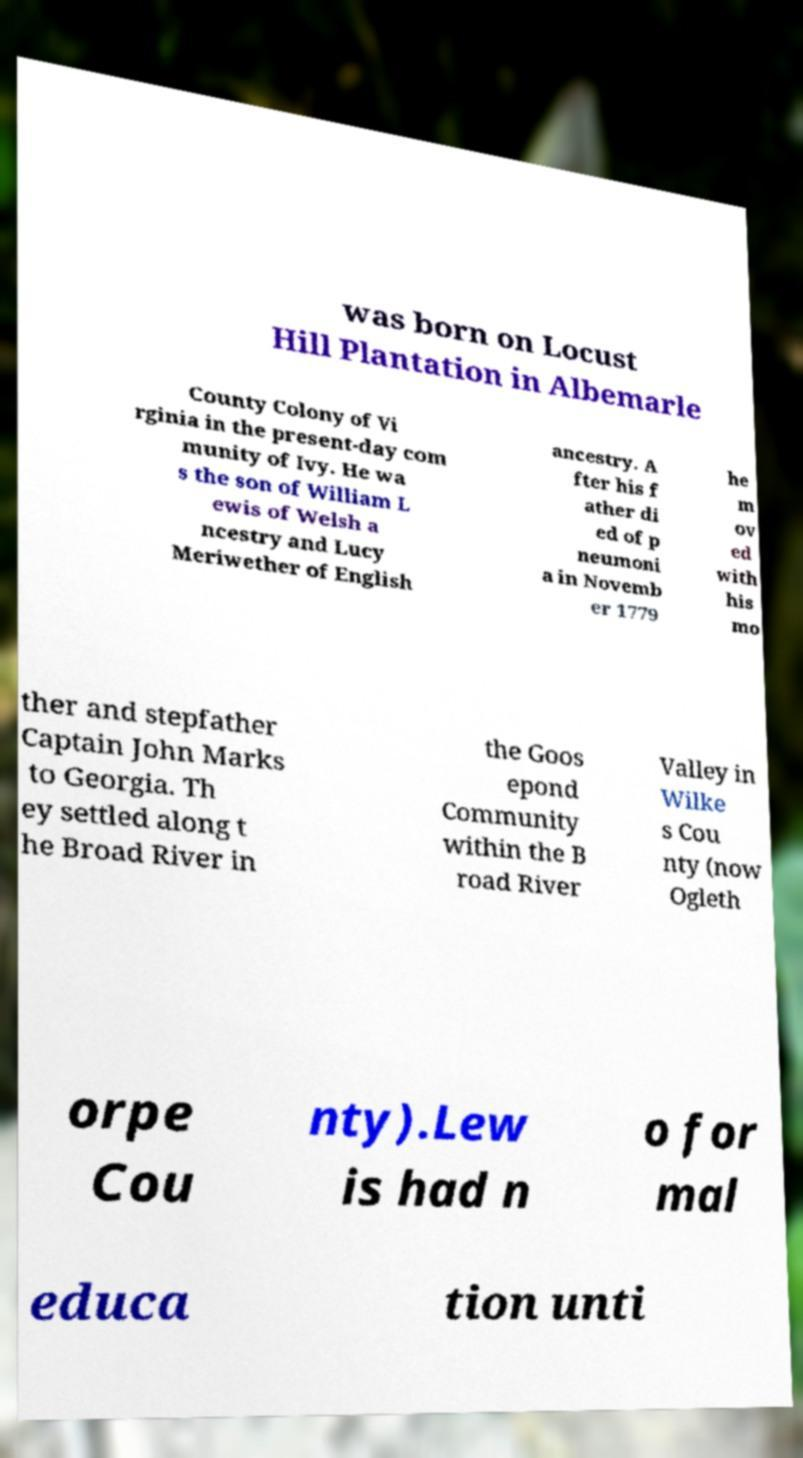Please read and relay the text visible in this image. What does it say? was born on Locust Hill Plantation in Albemarle County Colony of Vi rginia in the present-day com munity of Ivy. He wa s the son of William L ewis of Welsh a ncestry and Lucy Meriwether of English ancestry. A fter his f ather di ed of p neumoni a in Novemb er 1779 he m ov ed with his mo ther and stepfather Captain John Marks to Georgia. Th ey settled along t he Broad River in the Goos epond Community within the B road River Valley in Wilke s Cou nty (now Ogleth orpe Cou nty).Lew is had n o for mal educa tion unti 